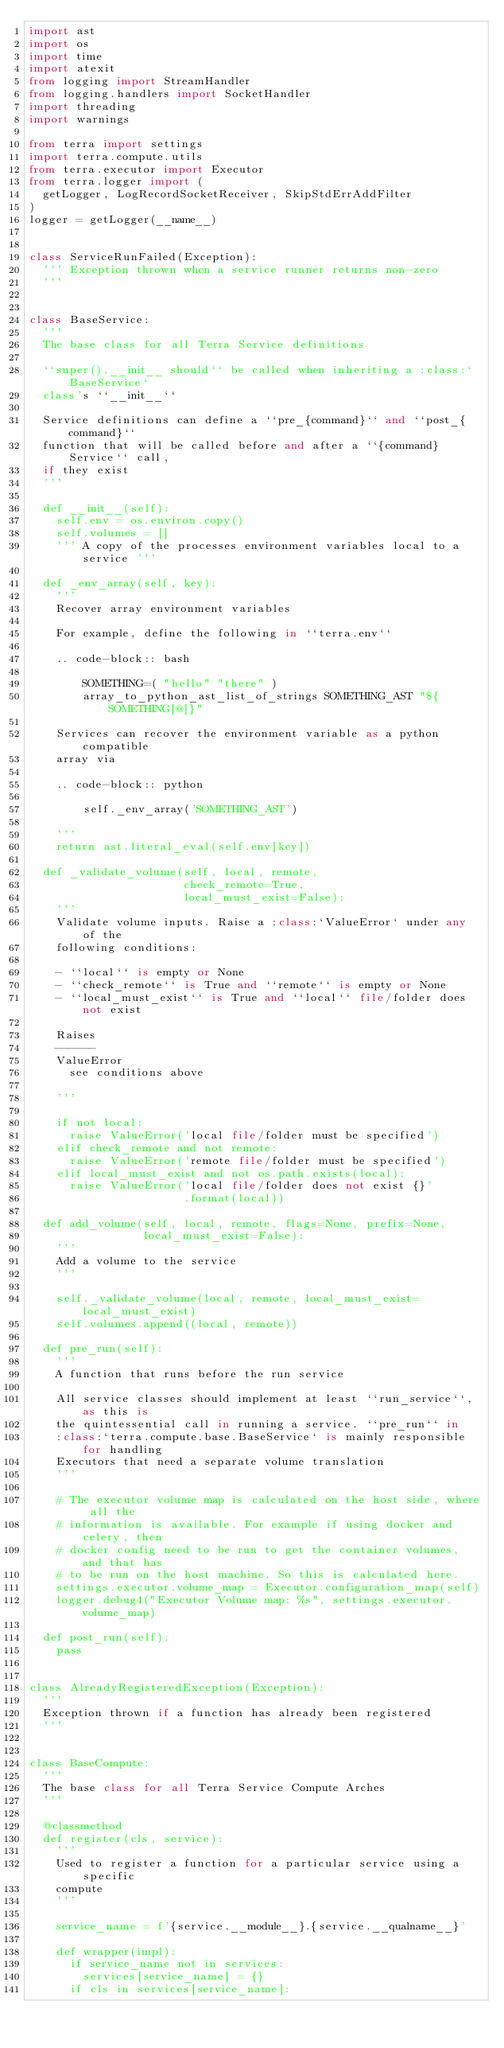Convert code to text. <code><loc_0><loc_0><loc_500><loc_500><_Python_>import ast
import os
import time
import atexit
from logging import StreamHandler
from logging.handlers import SocketHandler
import threading
import warnings

from terra import settings
import terra.compute.utils
from terra.executor import Executor
from terra.logger import (
  getLogger, LogRecordSocketReceiver, SkipStdErrAddFilter
)
logger = getLogger(__name__)


class ServiceRunFailed(Exception):
  ''' Exception thrown when a service runner returns non-zero
  '''


class BaseService:
  '''
  The base class for all Terra Service definitions

  ``super().__init__ should`` be called when inheriting a :class:`BaseService`
  class's ``__init__``

  Service definitions can define a ``pre_{command}`` and ``post_{command}``
  function that will be called before and after a ``{command}Service`` call,
  if they exist
  '''

  def __init__(self):
    self.env = os.environ.copy()
    self.volumes = []
    ''' A copy of the processes environment variables local to a service '''

  def _env_array(self, key):
    '''
    Recover array environment variables

    For example, define the following in ``terra.env``

    .. code-block:: bash

        SOMETHING=( "hello" "there" )
        array_to_python_ast_list_of_strings SOMETHING_AST "${SOMETHING[@]}"

    Services can recover the environment variable as a python compatible
    array via

    .. code-block:: python

        self._env_array('SOMETHING_AST')

    '''
    return ast.literal_eval(self.env[key])

  def _validate_volume(self, local, remote,
                       check_remote=True,
                       local_must_exist=False):
    '''
    Validate volume inputs. Raise a :class:`ValueError` under any of the
    following conditions:

    - ``local`` is empty or None
    - ``check_remote`` is True and ``remote`` is empty or None
    - ``local_must_exist`` is True and ``local`` file/folder does not exist

    Raises
    ------
    ValueError
      see conditions above

    '''

    if not local:
      raise ValueError('local file/folder must be specified')
    elif check_remote and not remote:
      raise ValueError('remote file/folder must be specified')
    elif local_must_exist and not os.path.exists(local):
      raise ValueError('local file/folder does not exist {}'
                       .format(local))

  def add_volume(self, local, remote, flags=None, prefix=None,
                 local_must_exist=False):
    '''
    Add a volume to the service
    '''

    self._validate_volume(local, remote, local_must_exist=local_must_exist)
    self.volumes.append((local, remote))

  def pre_run(self):
    '''
    A function that runs before the run service

    All service classes should implement at least ``run_service``, as this is
    the quintessential call in running a service. ``pre_run`` in
    :class:`terra.compute.base.BaseService` is mainly responsible for handling
    Executors that need a separate volume translation
    '''

    # The executor volume map is calculated on the host side, where all the
    # information is available. For example if using docker and celery, then
    # docker config need to be run to get the container volumes, and that has
    # to be run on the host machine. So this is calculated here.
    settings.executor.volume_map = Executor.configuration_map(self)
    logger.debug4("Executor Volume map: %s", settings.executor.volume_map)

  def post_run(self):
    pass


class AlreadyRegisteredException(Exception):
  '''
  Exception thrown if a function has already been registered
  '''


class BaseCompute:
  '''
  The base class for all Terra Service Compute Arches
  '''

  @classmethod
  def register(cls, service):
    '''
    Used to register a function for a particular service using a specific
    compute
    '''

    service_name = f'{service.__module__}.{service.__qualname__}'

    def wrapper(impl):
      if service_name not in services:
        services[service_name] = {}
      if cls in services[service_name]:</code> 